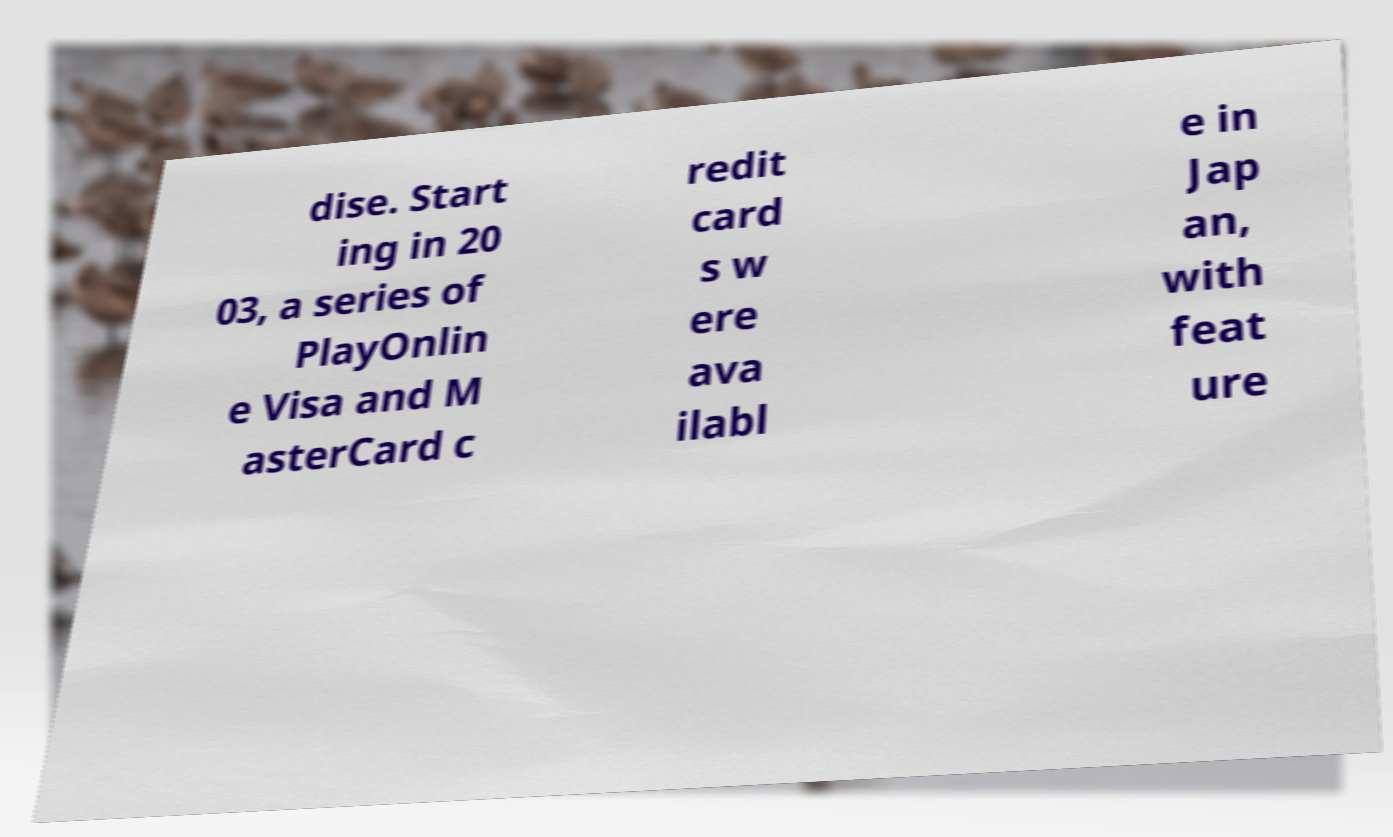Please read and relay the text visible in this image. What does it say? dise. Start ing in 20 03, a series of PlayOnlin e Visa and M asterCard c redit card s w ere ava ilabl e in Jap an, with feat ure 